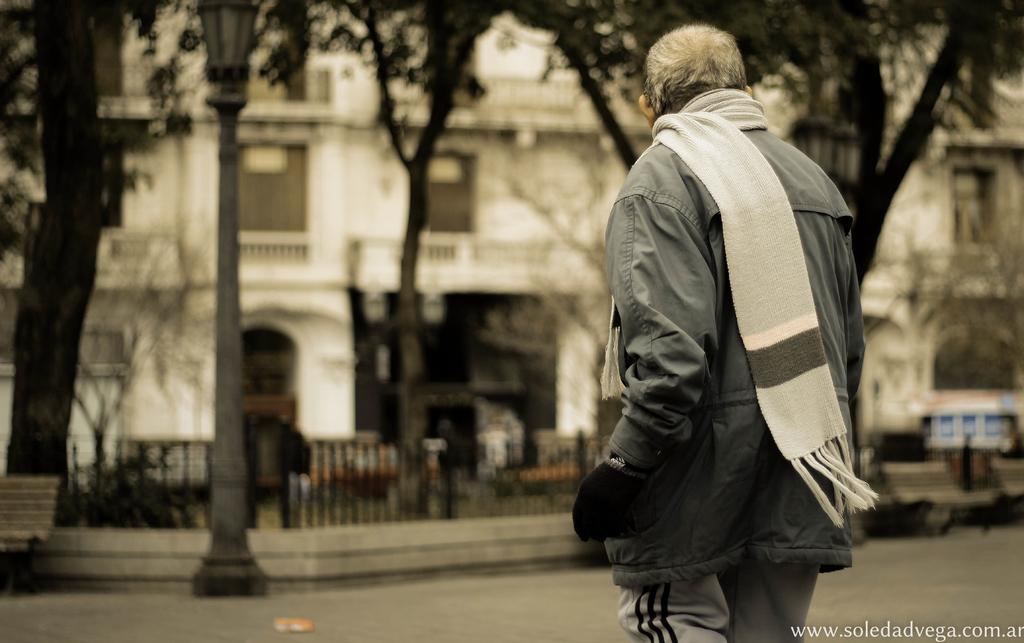What is the position of the man in the image? The man is standing on the right side of the image. What is the man wearing around his neck? The man has a cloth on his neck. Can you describe the background of the image? The background of the image is blurred, and there is a building, fences, trees, poles, and other objects visible. What type of advice is the man giving to the airplane in the image? There is no airplane present in the image, and therefore no such interaction can be observed. 